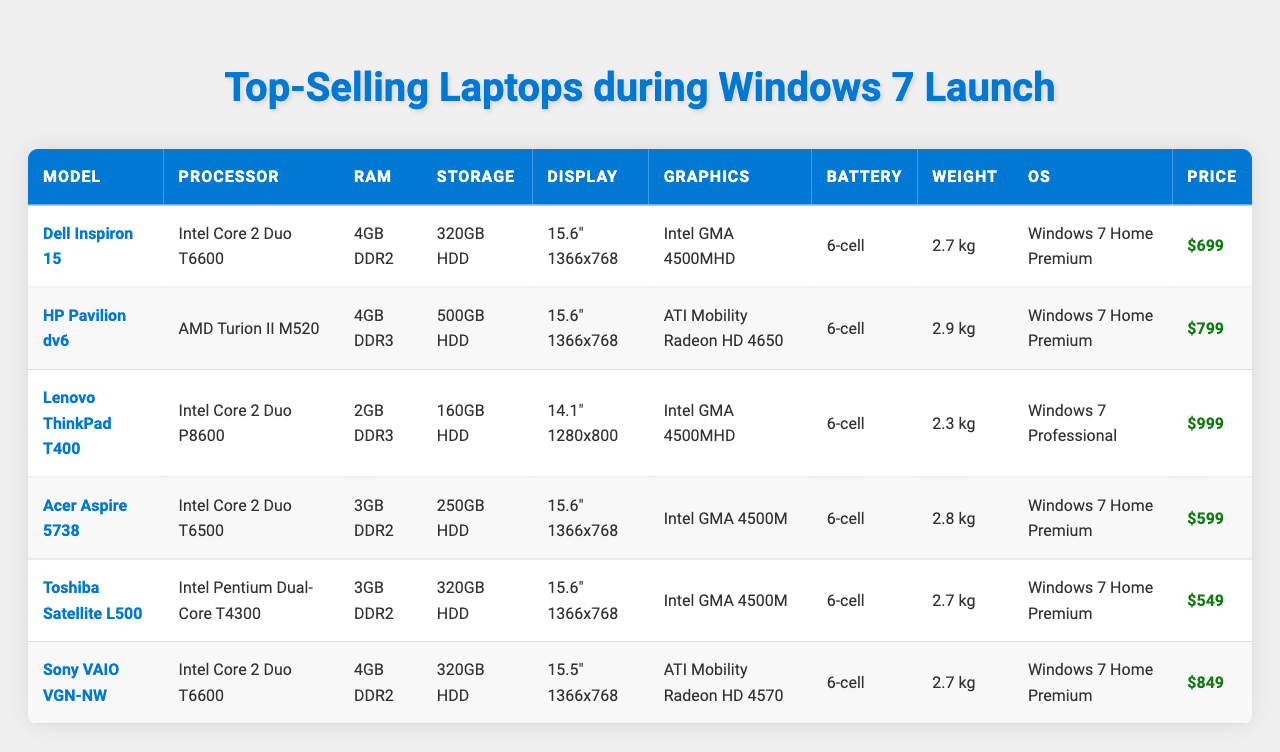What is the price of the HP Pavilion dv6? The price can be found in the table under the "Price" column corresponding to the HP Pavilion dv6 row. It states $799.
Answer: $799 Which laptop has the largest display resolution? The display resolution is given under the "Display" column. Comparing the values, the Lenovo ThinkPad T400 has a resolution of 1280x800, while others have 1366x768. Thus, the T400 has a larger resolution.
Answer: Lenovo ThinkPad T400 What is the total RAM of all the laptops listed? To find the total RAM, we add up the RAM values: 4GB + 4GB + 2GB + 3GB + 3GB + 4GB = 20GB. Thus, the total RAM is 20GB.
Answer: 20GB Which laptop is the lightest? The lightest laptop can be determined by comparing the weight values in the table. The Lenovo ThinkPad T400 weighs 2.3 kg, which is less than the others.
Answer: Lenovo ThinkPad T400 Is the Toshiba Satellite L500 heavier than the Acer Aspire 5738? The table lists the weights: Toshiba Satellite L500 at 2.7 kg and Acer Aspire 5738 at 2.8 kg. Since 2.7 kg is less than 2.8 kg, the statement is false.
Answer: No What is the difference in price between the most expensive and the least expensive laptop? The most expensive laptop is the Lenovo ThinkPad T400 at $999, and the least expensive is the Toshiba Satellite L500 at $549. The difference is $999 - $549 = $450.
Answer: $450 How many laptops have Intel processors? We check the "Processor" column for Intel processors. The Dell Inspiron 15, Lenovo ThinkPad T400, Acer Aspire 5738, and Sony VAIO VGN-NW all have Intel processors. This counts to 4 laptops.
Answer: 4 Which laptop has the best graphics card? We can evaluate the "Graphics" column. The HP Pavilion dv6 with ATI Mobility Radeon HD 4650 is considered the most capable among them compared to the others which have integrated graphics.
Answer: HP Pavilion dv6 What is the average weight of all the laptops? To find the average weight, we first sum the weights: 2.7 + 2.9 + 2.3 + 2.8 + 2.7 + 2.7 = 15.1 kg. Dividing this total by 6 (the number of laptops) gives us an average weight of 15.1/6 ≈ 2.52 kg.
Answer: 2.52 kg Can the Dell Inspiron 15 run Windows 10? The table indicates that the Dell Inspiron 15 runs Windows 7 Home Premium. Since it was released around the same time, it likely does not meet the requirements for Windows 10, hence the statement is false.
Answer: No Which laptop offers the least storage with HDD? We compare the "Storage" column: the Lenovo ThinkPad T400 has the least with 160GB HDD compared to the others that have more.
Answer: Lenovo ThinkPad T400 